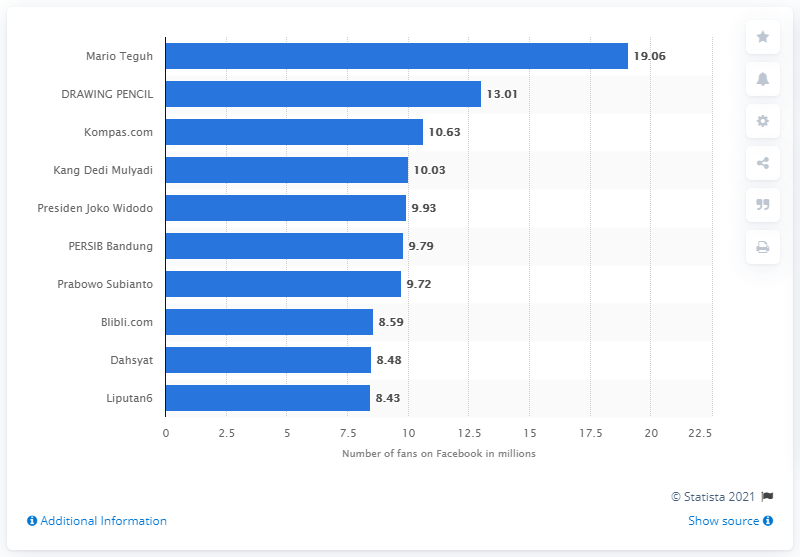Mention a couple of crucial points in this snapshot. Mario Teguh, an Indonesian motivational speaker, has 19 million followers on Facebook. 